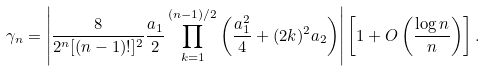Convert formula to latex. <formula><loc_0><loc_0><loc_500><loc_500>\gamma _ { n } = \left | \frac { 8 } { 2 ^ { n } [ ( n - 1 ) ! ] ^ { 2 } } \frac { a _ { 1 } } { 2 } \prod _ { k = 1 } ^ { ( n - 1 ) / 2 } \left ( \frac { a _ { 1 } ^ { 2 } } { 4 } + ( 2 k ) ^ { 2 } a _ { 2 } \right ) \right | \left [ 1 + O \left ( \frac { \log n } { n } \right ) \right ] .</formula> 